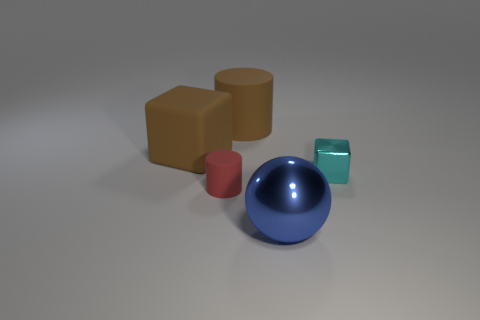Are there more small red rubber things than purple matte spheres?
Keep it short and to the point. Yes. What is the big blue thing made of?
Your answer should be compact. Metal. There is a large object to the left of the tiny red cylinder; what color is it?
Make the answer very short. Brown. Are there more brown rubber objects left of the sphere than big blocks right of the brown cylinder?
Ensure brevity in your answer.  Yes. There is a matte object that is to the left of the matte cylinder that is in front of the block that is to the right of the big rubber cylinder; what is its size?
Provide a short and direct response. Large. Are there any big metal spheres of the same color as the small metallic thing?
Your answer should be compact. No. What number of big things are there?
Make the answer very short. 3. The large thing on the left side of the brown object that is right of the big brown thing that is on the left side of the small cylinder is made of what material?
Ensure brevity in your answer.  Rubber. Are there any large blue objects that have the same material as the big brown cube?
Keep it short and to the point. No. Are the large brown block and the small cylinder made of the same material?
Provide a succinct answer. Yes. 